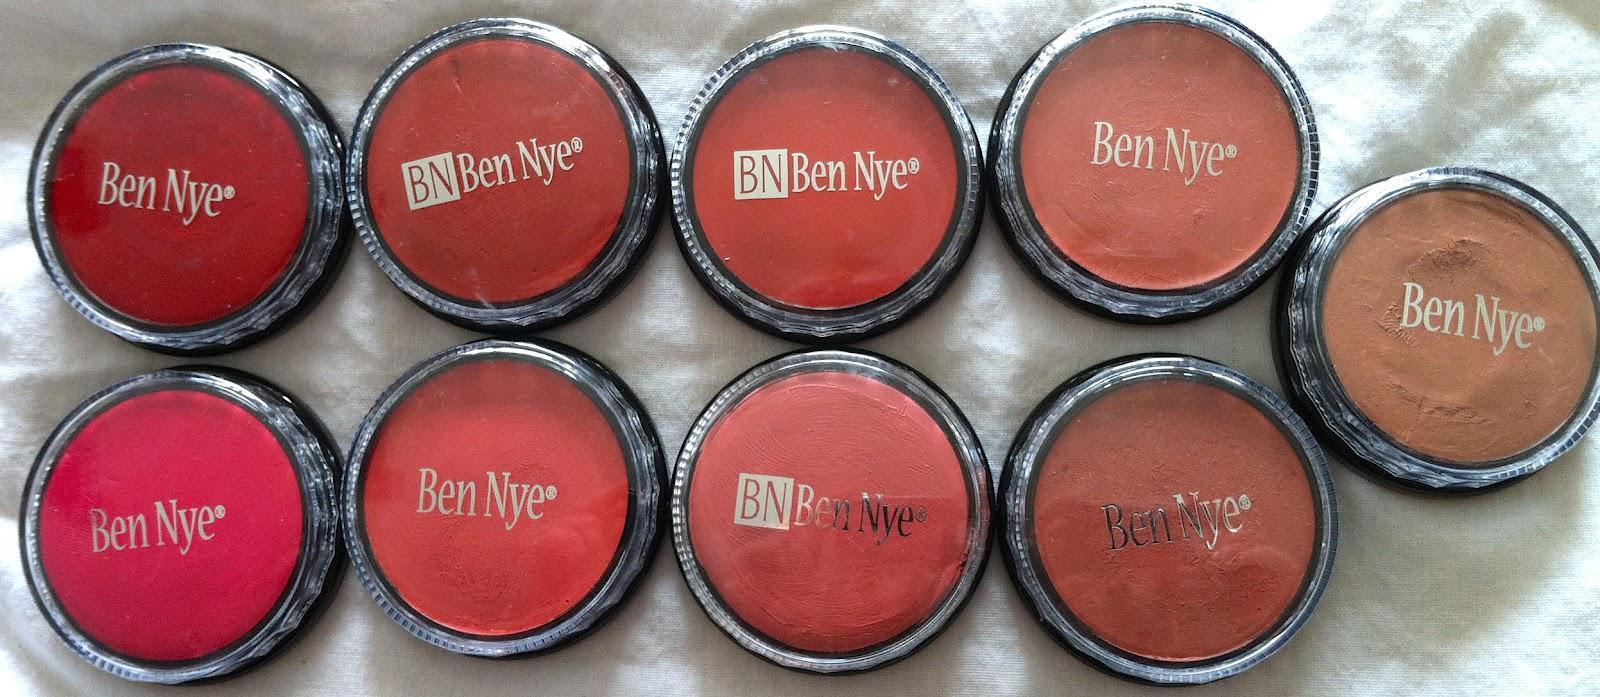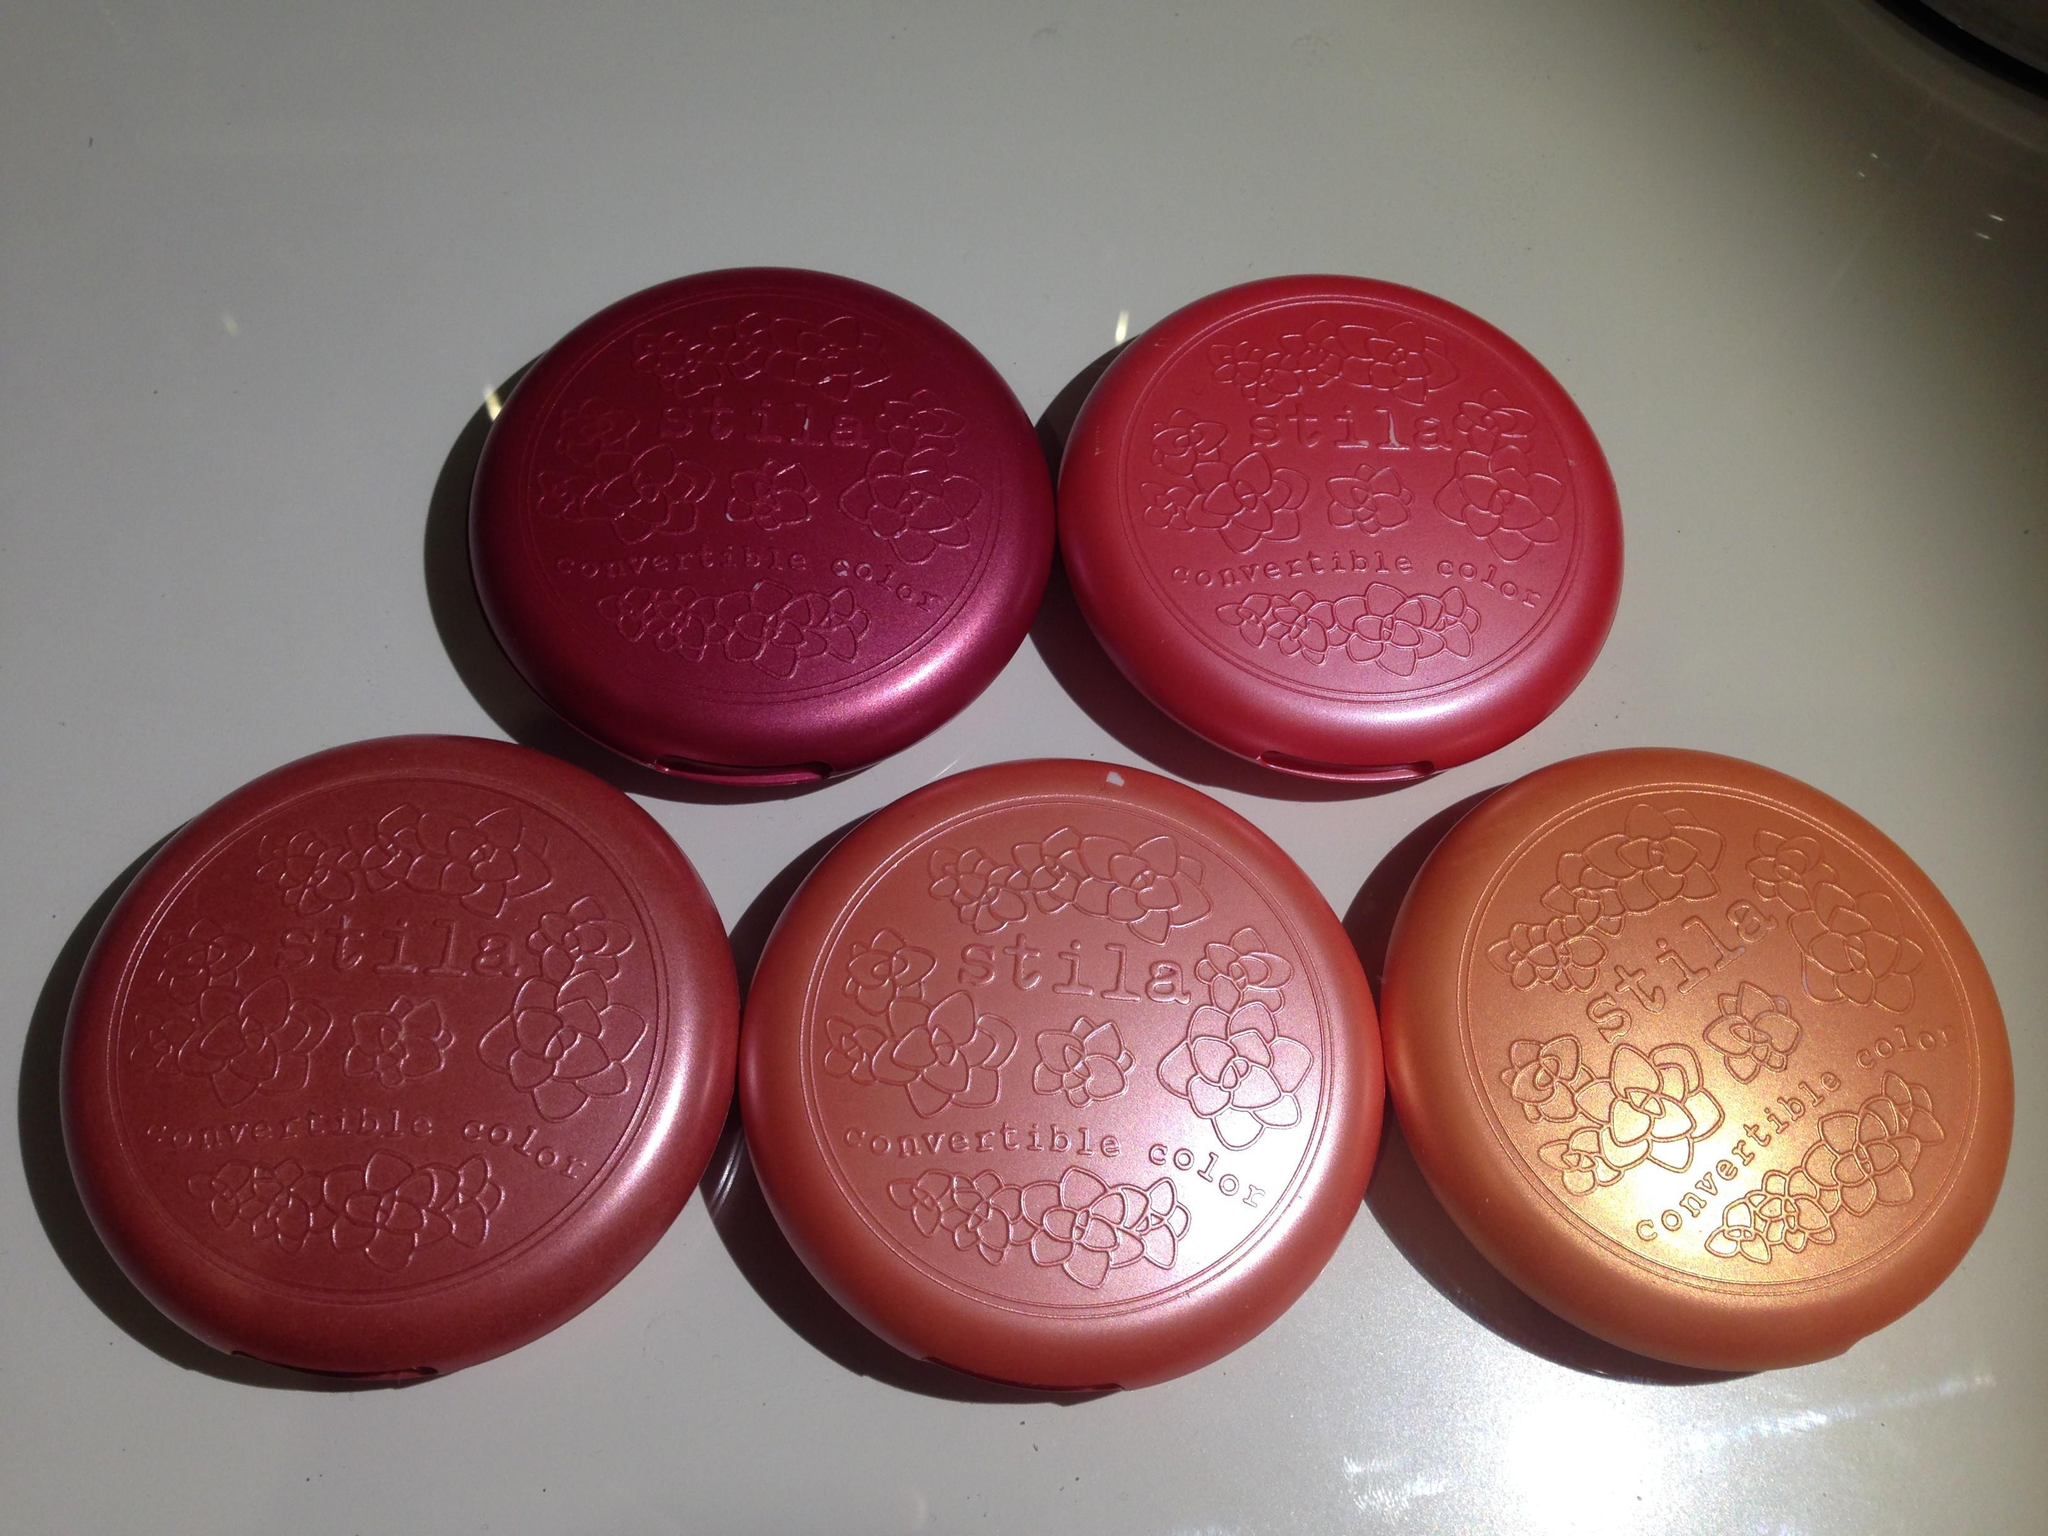The first image is the image on the left, the second image is the image on the right. Analyze the images presented: Is the assertion "There is at most 1 hand holding reddish makeup." valid? Answer yes or no. No. The first image is the image on the left, the second image is the image on the right. Given the left and right images, does the statement "One of the images in the pair shows a hand holding the makeup." hold true? Answer yes or no. No. 